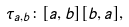Convert formula to latex. <formula><loc_0><loc_0><loc_500><loc_500>\tau _ { a , b } \colon [ a , b ] [ b , a ] ,</formula> 